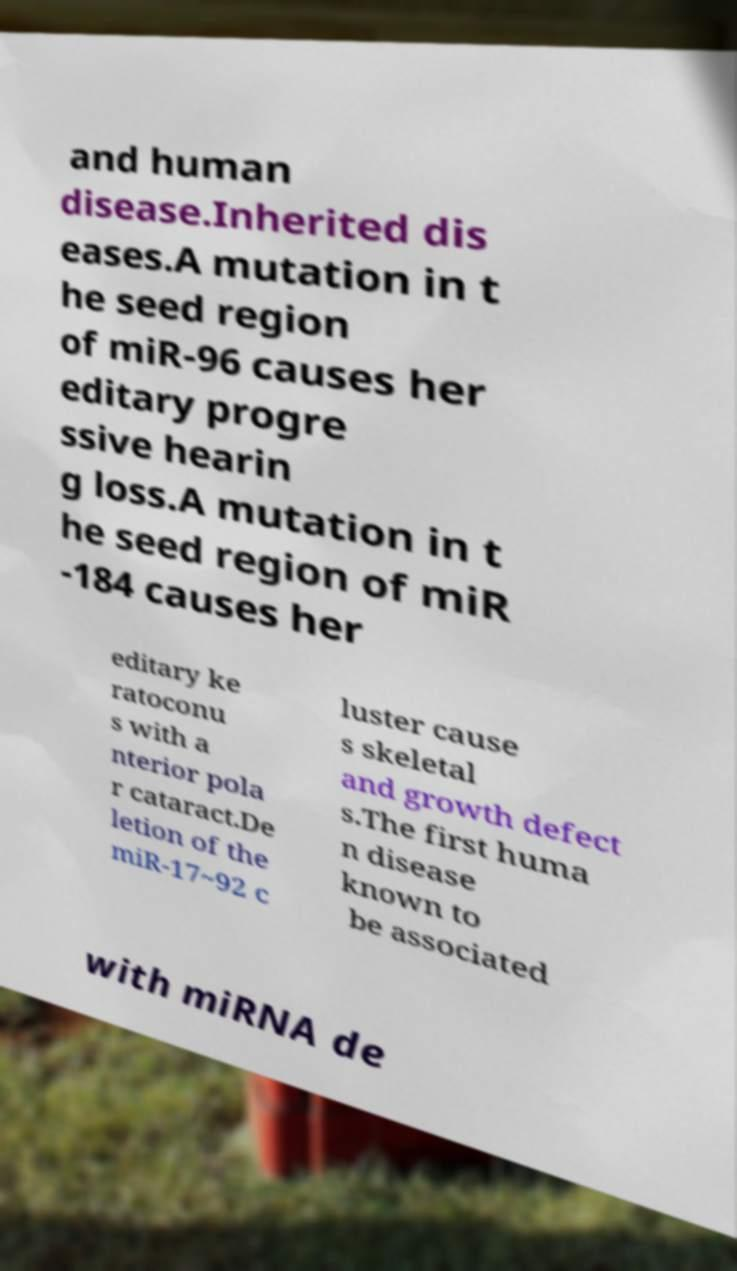Can you accurately transcribe the text from the provided image for me? and human disease.Inherited dis eases.A mutation in t he seed region of miR-96 causes her editary progre ssive hearin g loss.A mutation in t he seed region of miR -184 causes her editary ke ratoconu s with a nterior pola r cataract.De letion of the miR-17~92 c luster cause s skeletal and growth defect s.The first huma n disease known to be associated with miRNA de 